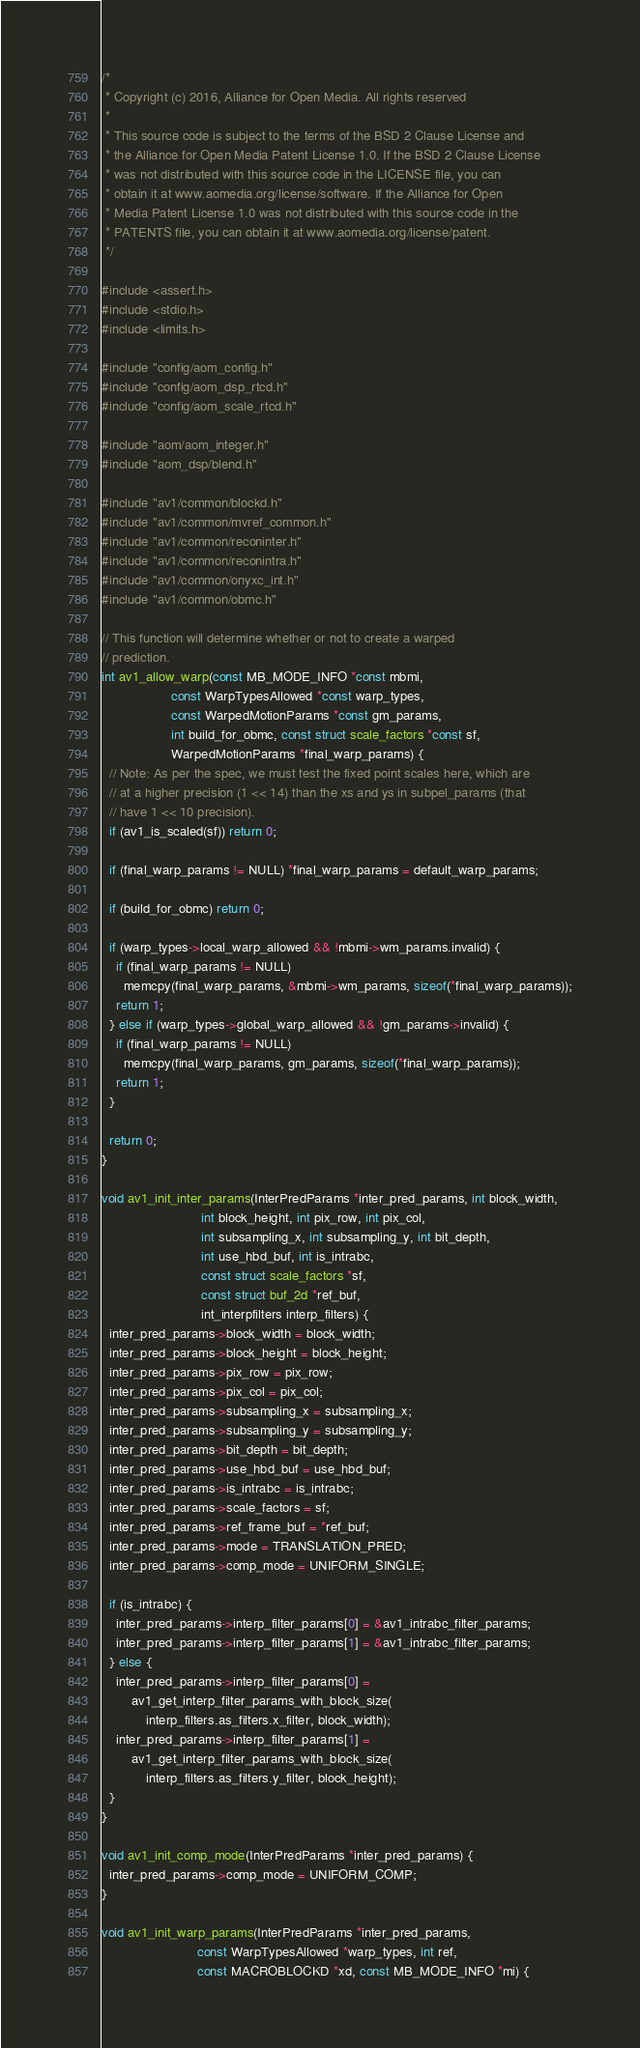Convert code to text. <code><loc_0><loc_0><loc_500><loc_500><_C_>/*
 * Copyright (c) 2016, Alliance for Open Media. All rights reserved
 *
 * This source code is subject to the terms of the BSD 2 Clause License and
 * the Alliance for Open Media Patent License 1.0. If the BSD 2 Clause License
 * was not distributed with this source code in the LICENSE file, you can
 * obtain it at www.aomedia.org/license/software. If the Alliance for Open
 * Media Patent License 1.0 was not distributed with this source code in the
 * PATENTS file, you can obtain it at www.aomedia.org/license/patent.
 */

#include <assert.h>
#include <stdio.h>
#include <limits.h>

#include "config/aom_config.h"
#include "config/aom_dsp_rtcd.h"
#include "config/aom_scale_rtcd.h"

#include "aom/aom_integer.h"
#include "aom_dsp/blend.h"

#include "av1/common/blockd.h"
#include "av1/common/mvref_common.h"
#include "av1/common/reconinter.h"
#include "av1/common/reconintra.h"
#include "av1/common/onyxc_int.h"
#include "av1/common/obmc.h"

// This function will determine whether or not to create a warped
// prediction.
int av1_allow_warp(const MB_MODE_INFO *const mbmi,
                   const WarpTypesAllowed *const warp_types,
                   const WarpedMotionParams *const gm_params,
                   int build_for_obmc, const struct scale_factors *const sf,
                   WarpedMotionParams *final_warp_params) {
  // Note: As per the spec, we must test the fixed point scales here, which are
  // at a higher precision (1 << 14) than the xs and ys in subpel_params (that
  // have 1 << 10 precision).
  if (av1_is_scaled(sf)) return 0;

  if (final_warp_params != NULL) *final_warp_params = default_warp_params;

  if (build_for_obmc) return 0;

  if (warp_types->local_warp_allowed && !mbmi->wm_params.invalid) {
    if (final_warp_params != NULL)
      memcpy(final_warp_params, &mbmi->wm_params, sizeof(*final_warp_params));
    return 1;
  } else if (warp_types->global_warp_allowed && !gm_params->invalid) {
    if (final_warp_params != NULL)
      memcpy(final_warp_params, gm_params, sizeof(*final_warp_params));
    return 1;
  }

  return 0;
}

void av1_init_inter_params(InterPredParams *inter_pred_params, int block_width,
                           int block_height, int pix_row, int pix_col,
                           int subsampling_x, int subsampling_y, int bit_depth,
                           int use_hbd_buf, int is_intrabc,
                           const struct scale_factors *sf,
                           const struct buf_2d *ref_buf,
                           int_interpfilters interp_filters) {
  inter_pred_params->block_width = block_width;
  inter_pred_params->block_height = block_height;
  inter_pred_params->pix_row = pix_row;
  inter_pred_params->pix_col = pix_col;
  inter_pred_params->subsampling_x = subsampling_x;
  inter_pred_params->subsampling_y = subsampling_y;
  inter_pred_params->bit_depth = bit_depth;
  inter_pred_params->use_hbd_buf = use_hbd_buf;
  inter_pred_params->is_intrabc = is_intrabc;
  inter_pred_params->scale_factors = sf;
  inter_pred_params->ref_frame_buf = *ref_buf;
  inter_pred_params->mode = TRANSLATION_PRED;
  inter_pred_params->comp_mode = UNIFORM_SINGLE;

  if (is_intrabc) {
    inter_pred_params->interp_filter_params[0] = &av1_intrabc_filter_params;
    inter_pred_params->interp_filter_params[1] = &av1_intrabc_filter_params;
  } else {
    inter_pred_params->interp_filter_params[0] =
        av1_get_interp_filter_params_with_block_size(
            interp_filters.as_filters.x_filter, block_width);
    inter_pred_params->interp_filter_params[1] =
        av1_get_interp_filter_params_with_block_size(
            interp_filters.as_filters.y_filter, block_height);
  }
}

void av1_init_comp_mode(InterPredParams *inter_pred_params) {
  inter_pred_params->comp_mode = UNIFORM_COMP;
}

void av1_init_warp_params(InterPredParams *inter_pred_params,
                          const WarpTypesAllowed *warp_types, int ref,
                          const MACROBLOCKD *xd, const MB_MODE_INFO *mi) {</code> 